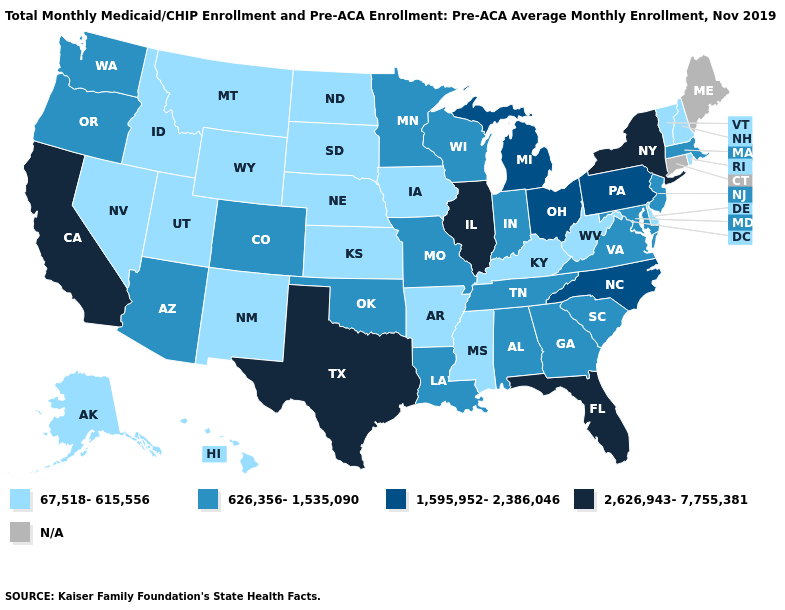What is the highest value in the USA?
Quick response, please. 2,626,943-7,755,381. How many symbols are there in the legend?
Quick response, please. 5. Name the states that have a value in the range 2,626,943-7,755,381?
Keep it brief. California, Florida, Illinois, New York, Texas. Name the states that have a value in the range 67,518-615,556?
Short answer required. Alaska, Arkansas, Delaware, Hawaii, Idaho, Iowa, Kansas, Kentucky, Mississippi, Montana, Nebraska, Nevada, New Hampshire, New Mexico, North Dakota, Rhode Island, South Dakota, Utah, Vermont, West Virginia, Wyoming. What is the value of New Jersey?
Be succinct. 626,356-1,535,090. Name the states that have a value in the range N/A?
Give a very brief answer. Connecticut, Maine. Name the states that have a value in the range 1,595,952-2,386,046?
Short answer required. Michigan, North Carolina, Ohio, Pennsylvania. Which states have the lowest value in the West?
Quick response, please. Alaska, Hawaii, Idaho, Montana, Nevada, New Mexico, Utah, Wyoming. Which states have the highest value in the USA?
Give a very brief answer. California, Florida, Illinois, New York, Texas. What is the value of Rhode Island?
Give a very brief answer. 67,518-615,556. What is the value of Georgia?
Give a very brief answer. 626,356-1,535,090. Name the states that have a value in the range N/A?
Quick response, please. Connecticut, Maine. Which states have the lowest value in the USA?
Keep it brief. Alaska, Arkansas, Delaware, Hawaii, Idaho, Iowa, Kansas, Kentucky, Mississippi, Montana, Nebraska, Nevada, New Hampshire, New Mexico, North Dakota, Rhode Island, South Dakota, Utah, Vermont, West Virginia, Wyoming. Name the states that have a value in the range 626,356-1,535,090?
Be succinct. Alabama, Arizona, Colorado, Georgia, Indiana, Louisiana, Maryland, Massachusetts, Minnesota, Missouri, New Jersey, Oklahoma, Oregon, South Carolina, Tennessee, Virginia, Washington, Wisconsin. Which states have the highest value in the USA?
Short answer required. California, Florida, Illinois, New York, Texas. 